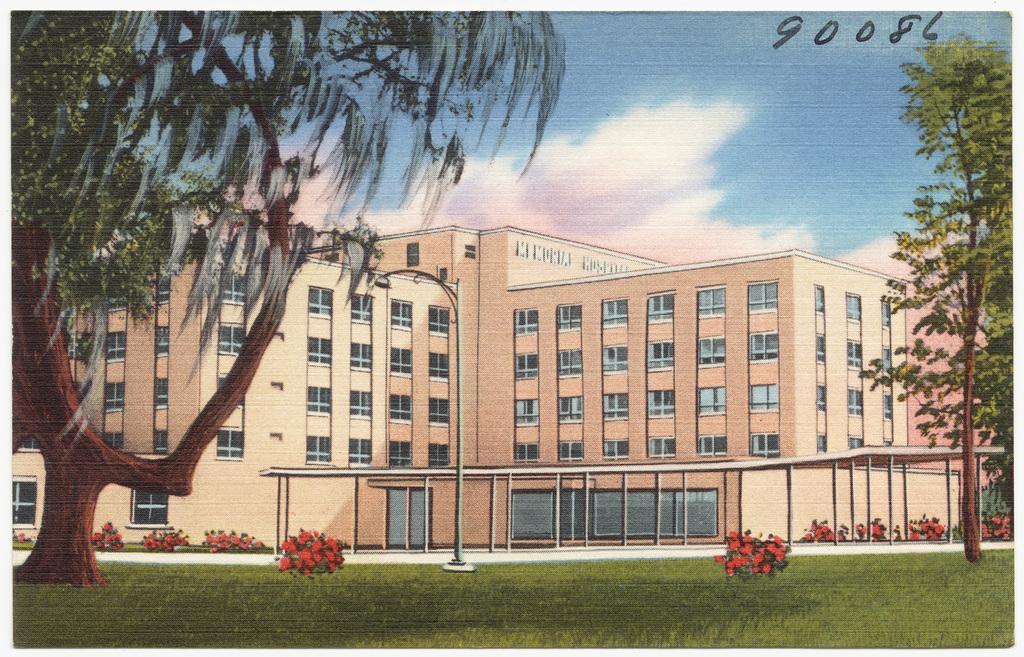How would you summarize this image in a sentence or two? In this picture we can see the painting of outside which includes green grass, plants, trees, buildings, street light, pole, sky and clouds. 